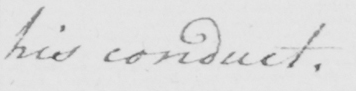Please provide the text content of this handwritten line. his conduct . 